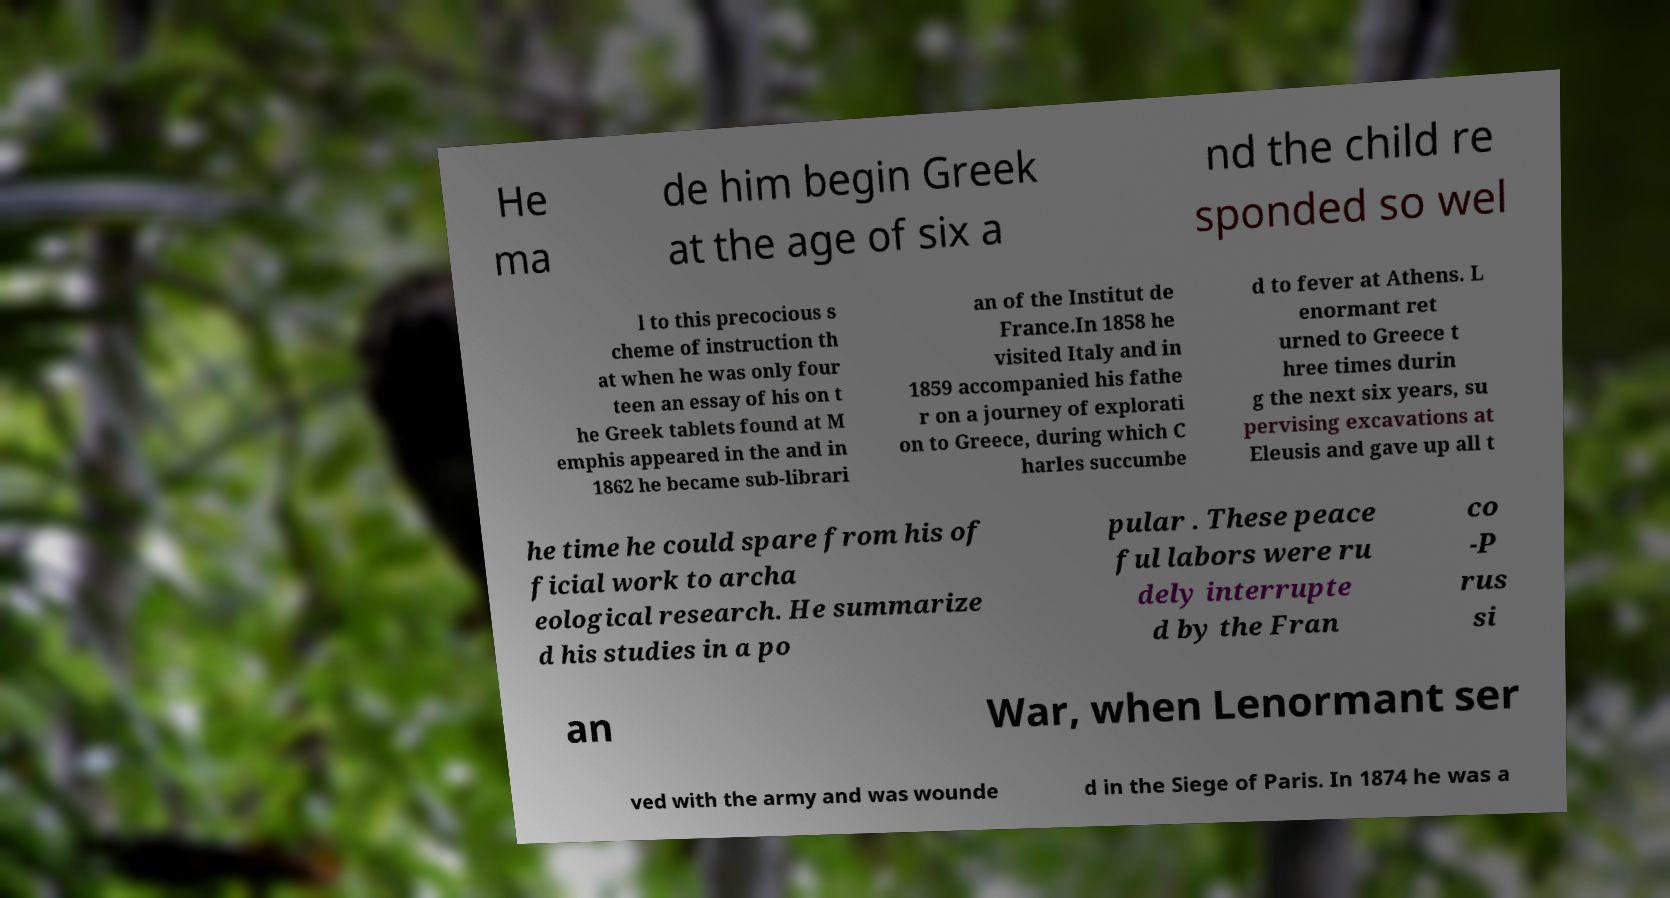Could you extract and type out the text from this image? He ma de him begin Greek at the age of six a nd the child re sponded so wel l to this precocious s cheme of instruction th at when he was only four teen an essay of his on t he Greek tablets found at M emphis appeared in the and in 1862 he became sub-librari an of the Institut de France.In 1858 he visited Italy and in 1859 accompanied his fathe r on a journey of explorati on to Greece, during which C harles succumbe d to fever at Athens. L enormant ret urned to Greece t hree times durin g the next six years, su pervising excavations at Eleusis and gave up all t he time he could spare from his of ficial work to archa eological research. He summarize d his studies in a po pular . These peace ful labors were ru dely interrupte d by the Fran co -P rus si an War, when Lenormant ser ved with the army and was wounde d in the Siege of Paris. In 1874 he was a 